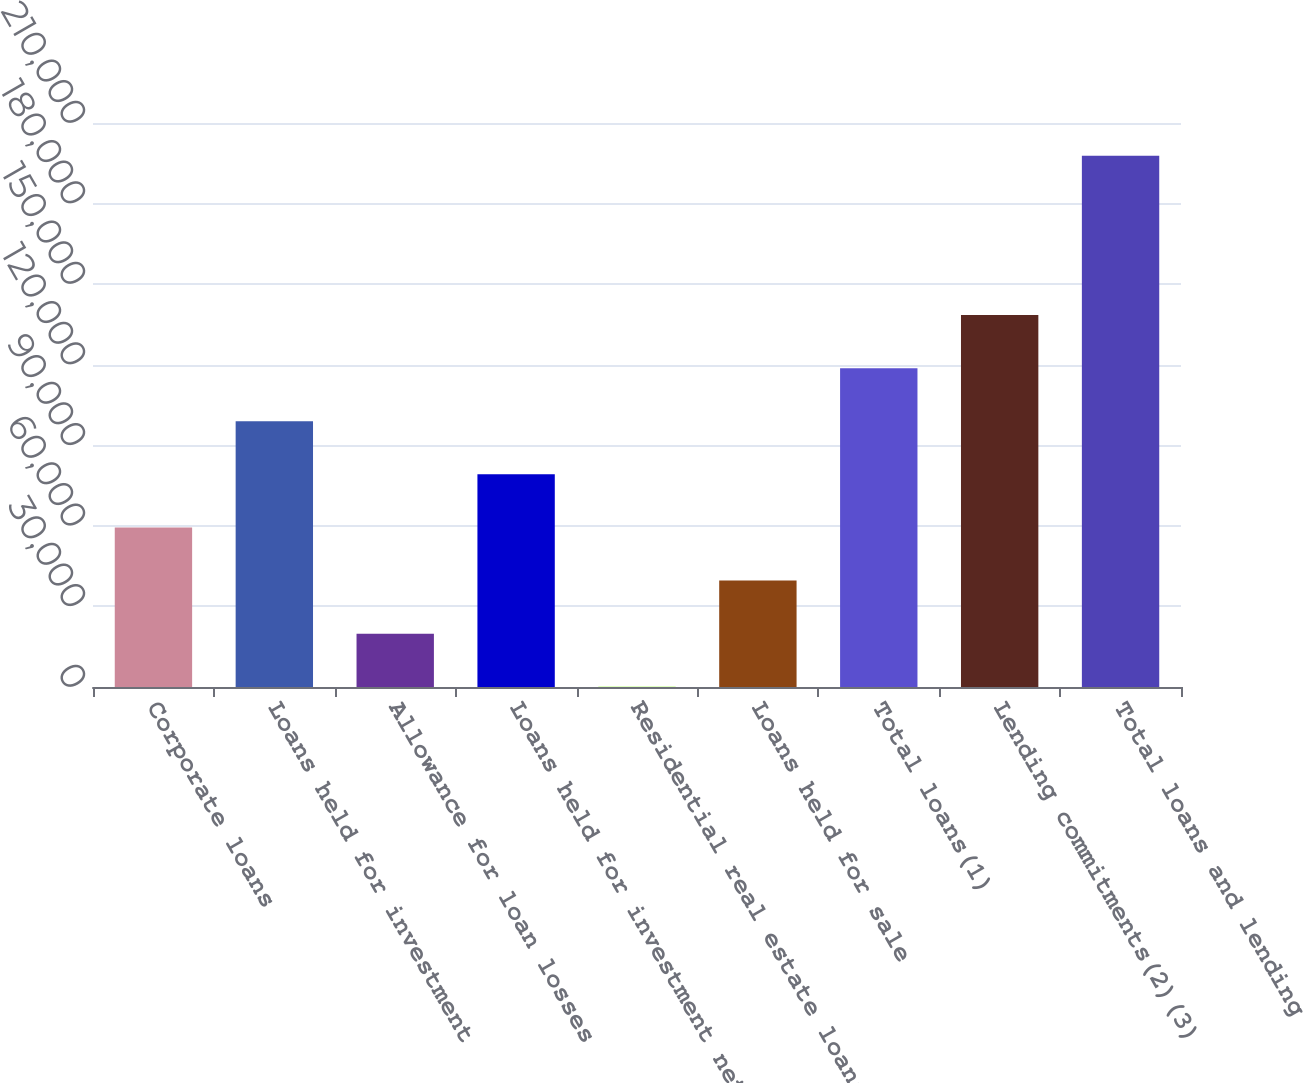Convert chart. <chart><loc_0><loc_0><loc_500><loc_500><bar_chart><fcel>Corporate loans<fcel>Loans held for investment<fcel>Allowance for loan losses<fcel>Loans held for investment net<fcel>Residential real estate loans<fcel>Loans held for sale<fcel>Total loans(1)<fcel>Lending commitments(2)(3)<fcel>Total loans and lending<nl><fcel>59403.8<fcel>98937<fcel>19870.6<fcel>79170.4<fcel>104<fcel>39637.2<fcel>118704<fcel>138470<fcel>197770<nl></chart> 